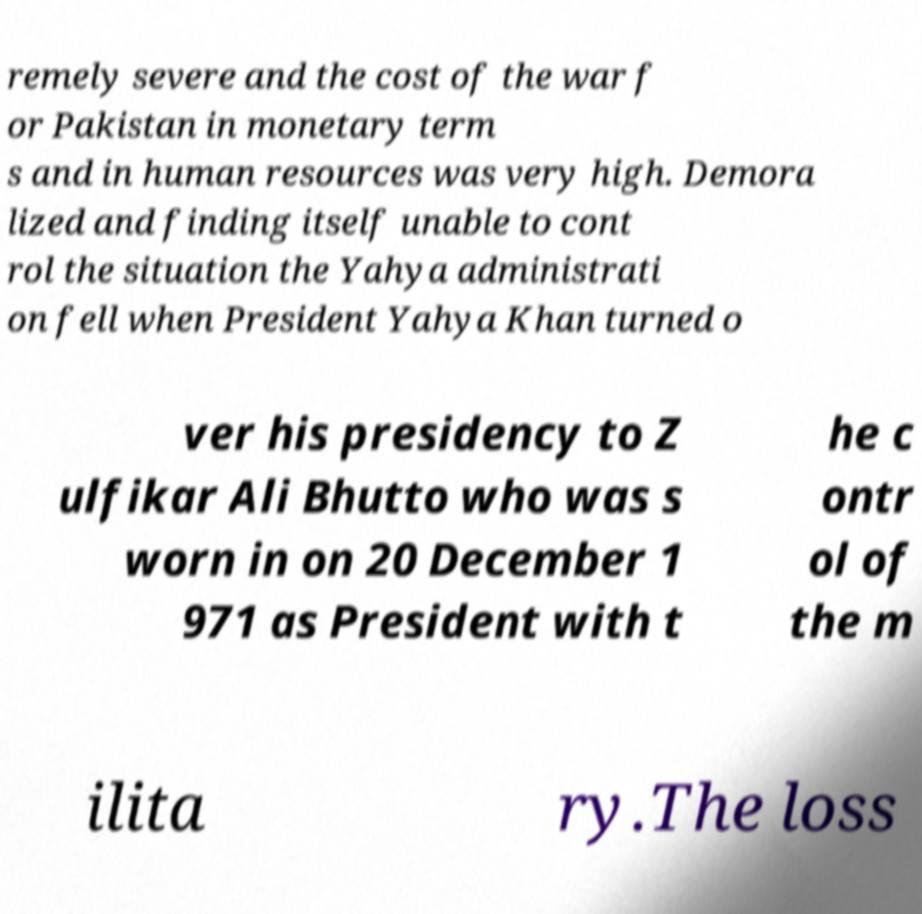What messages or text are displayed in this image? I need them in a readable, typed format. remely severe and the cost of the war f or Pakistan in monetary term s and in human resources was very high. Demora lized and finding itself unable to cont rol the situation the Yahya administrati on fell when President Yahya Khan turned o ver his presidency to Z ulfikar Ali Bhutto who was s worn in on 20 December 1 971 as President with t he c ontr ol of the m ilita ry.The loss 